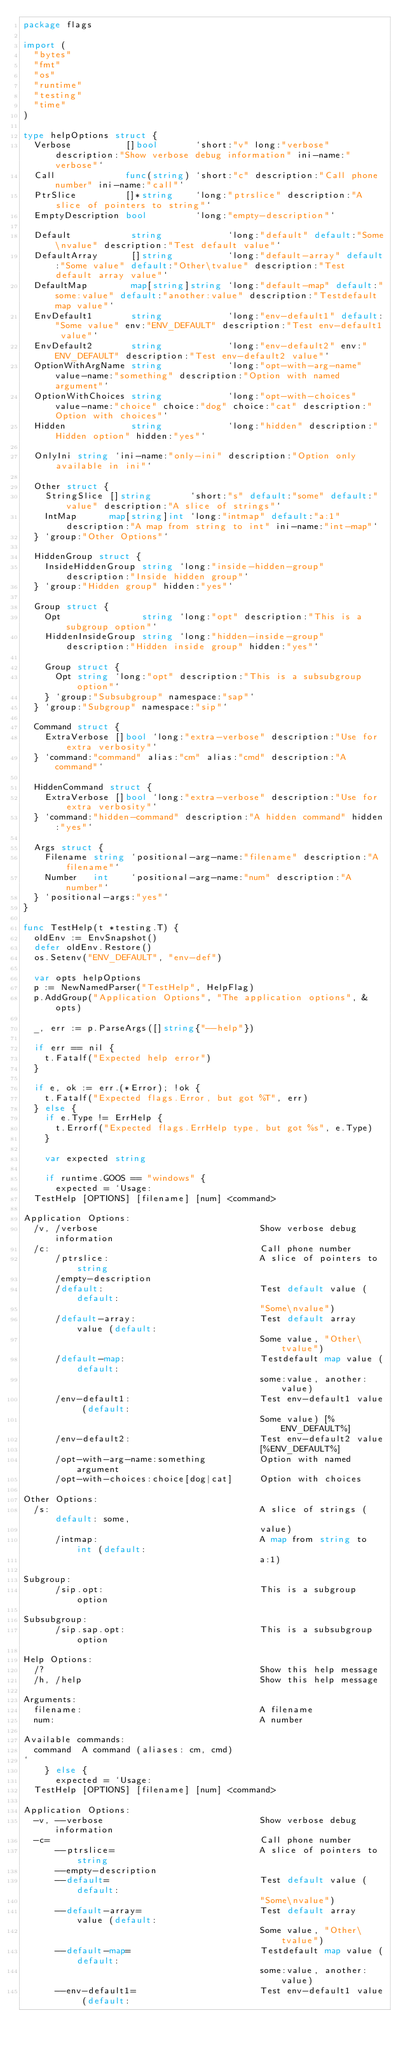Convert code to text. <code><loc_0><loc_0><loc_500><loc_500><_Go_>package flags

import (
	"bytes"
	"fmt"
	"os"
	"runtime"
	"testing"
	"time"
)

type helpOptions struct {
	Verbose          []bool       `short:"v" long:"verbose" description:"Show verbose debug information" ini-name:"verbose"`
	Call             func(string) `short:"c" description:"Call phone number" ini-name:"call"`
	PtrSlice         []*string    `long:"ptrslice" description:"A slice of pointers to string"`
	EmptyDescription bool         `long:"empty-description"`

	Default           string            `long:"default" default:"Some\nvalue" description:"Test default value"`
	DefaultArray      []string          `long:"default-array" default:"Some value" default:"Other\tvalue" description:"Test default array value"`
	DefaultMap        map[string]string `long:"default-map" default:"some:value" default:"another:value" description:"Testdefault map value"`
	EnvDefault1       string            `long:"env-default1" default:"Some value" env:"ENV_DEFAULT" description:"Test env-default1 value"`
	EnvDefault2       string            `long:"env-default2" env:"ENV_DEFAULT" description:"Test env-default2 value"`
	OptionWithArgName string            `long:"opt-with-arg-name" value-name:"something" description:"Option with named argument"`
	OptionWithChoices string            `long:"opt-with-choices" value-name:"choice" choice:"dog" choice:"cat" description:"Option with choices"`
	Hidden            string            `long:"hidden" description:"Hidden option" hidden:"yes"`

	OnlyIni string `ini-name:"only-ini" description:"Option only available in ini"`

	Other struct {
		StringSlice []string       `short:"s" default:"some" default:"value" description:"A slice of strings"`
		IntMap      map[string]int `long:"intmap" default:"a:1" description:"A map from string to int" ini-name:"int-map"`
	} `group:"Other Options"`

	HiddenGroup struct {
		InsideHiddenGroup string `long:"inside-hidden-group" description:"Inside hidden group"`
	} `group:"Hidden group" hidden:"yes"`

	Group struct {
		Opt               string `long:"opt" description:"This is a subgroup option"`
		HiddenInsideGroup string `long:"hidden-inside-group" description:"Hidden inside group" hidden:"yes"`

		Group struct {
			Opt string `long:"opt" description:"This is a subsubgroup option"`
		} `group:"Subsubgroup" namespace:"sap"`
	} `group:"Subgroup" namespace:"sip"`

	Command struct {
		ExtraVerbose []bool `long:"extra-verbose" description:"Use for extra verbosity"`
	} `command:"command" alias:"cm" alias:"cmd" description:"A command"`

	HiddenCommand struct {
		ExtraVerbose []bool `long:"extra-verbose" description:"Use for extra verbosity"`
	} `command:"hidden-command" description:"A hidden command" hidden:"yes"`

	Args struct {
		Filename string `positional-arg-name:"filename" description:"A filename"`
		Number   int    `positional-arg-name:"num" description:"A number"`
	} `positional-args:"yes"`
}

func TestHelp(t *testing.T) {
	oldEnv := EnvSnapshot()
	defer oldEnv.Restore()
	os.Setenv("ENV_DEFAULT", "env-def")

	var opts helpOptions
	p := NewNamedParser("TestHelp", HelpFlag)
	p.AddGroup("Application Options", "The application options", &opts)

	_, err := p.ParseArgs([]string{"--help"})

	if err == nil {
		t.Fatalf("Expected help error")
	}

	if e, ok := err.(*Error); !ok {
		t.Fatalf("Expected flags.Error, but got %T", err)
	} else {
		if e.Type != ErrHelp {
			t.Errorf("Expected flags.ErrHelp type, but got %s", e.Type)
		}

		var expected string

		if runtime.GOOS == "windows" {
			expected = `Usage:
  TestHelp [OPTIONS] [filename] [num] <command>

Application Options:
  /v, /verbose                              Show verbose debug information
  /c:                                       Call phone number
      /ptrslice:                            A slice of pointers to string
      /empty-description
      /default:                             Test default value (default:
                                            "Some\nvalue")
      /default-array:                       Test default array value (default:
                                            Some value, "Other\tvalue")
      /default-map:                         Testdefault map value (default:
                                            some:value, another:value)
      /env-default1:                        Test env-default1 value (default:
                                            Some value) [%ENV_DEFAULT%]
      /env-default2:                        Test env-default2 value
                                            [%ENV_DEFAULT%]
      /opt-with-arg-name:something          Option with named argument
      /opt-with-choices:choice[dog|cat]     Option with choices

Other Options:
  /s:                                       A slice of strings (default: some,
                                            value)
      /intmap:                              A map from string to int (default:
                                            a:1)

Subgroup:
      /sip.opt:                             This is a subgroup option

Subsubgroup:
      /sip.sap.opt:                         This is a subsubgroup option

Help Options:
  /?                                        Show this help message
  /h, /help                                 Show this help message

Arguments:
  filename:                                 A filename
  num:                                      A number

Available commands:
  command  A command (aliases: cm, cmd)
`
		} else {
			expected = `Usage:
  TestHelp [OPTIONS] [filename] [num] <command>

Application Options:
  -v, --verbose                             Show verbose debug information
  -c=                                       Call phone number
      --ptrslice=                           A slice of pointers to string
      --empty-description
      --default=                            Test default value (default:
                                            "Some\nvalue")
      --default-array=                      Test default array value (default:
                                            Some value, "Other\tvalue")
      --default-map=                        Testdefault map value (default:
                                            some:value, another:value)
      --env-default1=                       Test env-default1 value (default:</code> 